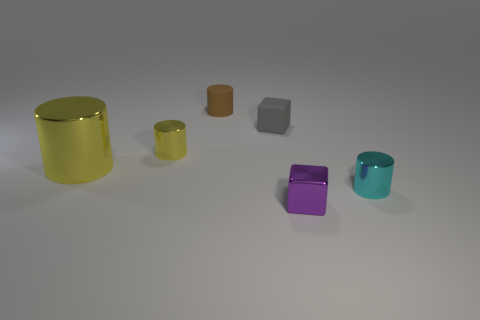Is there a color theme among the objects? The objects feature a variety of colors including yellow, orange, grey, purple, and cyan, indicating no strict color theme but rather a showcasing of diversity in hues. 